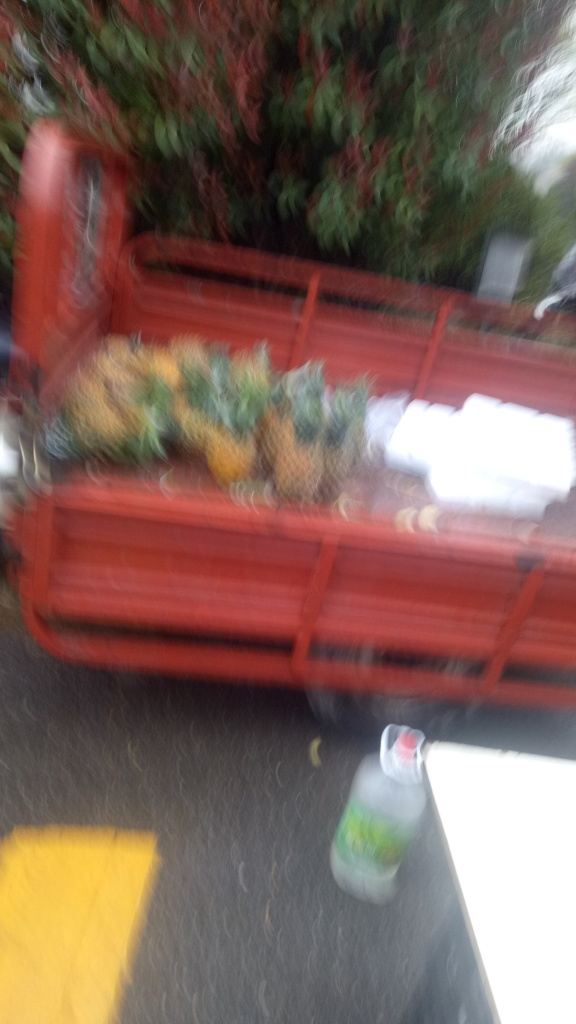What does the presence of the pineapples in the cart suggest about the location or context of this photograph? The pineapples in the cart hint at a tropical or subtropical setting, potentially a market or an area where fresh produce is sold. It suggests an environment where pineapples are either grown locally or are a common part of the diet. What time of day does this photo appear to have been taken, given the available lighting? Given the overall brightness and the visibility despite the blur, it seems that the photo was taken during daylight hours. However, without shadows or direct light sources being distinguishable, it’s challenging to specify the exact time of day. 